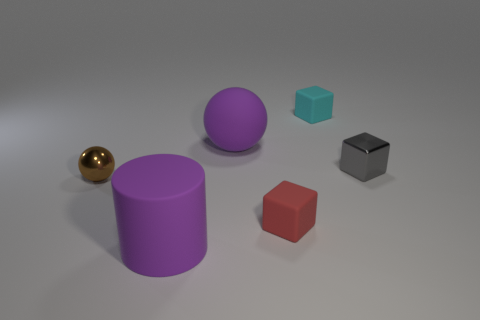Subtract all gray cubes. How many cubes are left? 2 Add 1 gray metallic blocks. How many objects exist? 7 Subtract all red blocks. How many blocks are left? 2 Subtract 1 cubes. How many cubes are left? 2 Subtract all balls. How many objects are left? 4 Add 5 tiny gray metal cubes. How many tiny gray metal cubes are left? 6 Add 6 big green metallic balls. How many big green metallic balls exist? 6 Subtract 0 yellow cylinders. How many objects are left? 6 Subtract all green balls. Subtract all blue cylinders. How many balls are left? 2 Subtract all large things. Subtract all large purple cylinders. How many objects are left? 3 